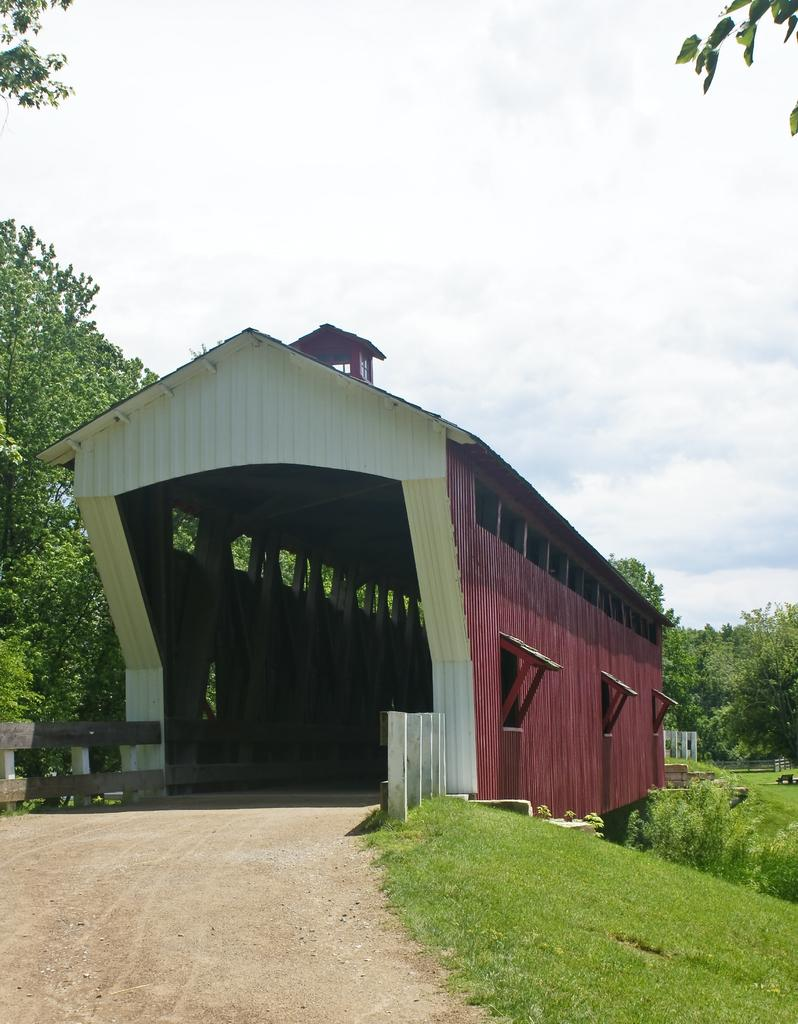What type of structure is visible in the image? There is a shed in the image. What can be seen in the background of the image? There are many trees, plants, and grass in the background of the image. What type of fencing is present on the left side of the image? There is wooden fencing on the left side of the image. What is visible at the top of the image? The sky is visible at the top of the image, and clouds are present in the sky. What type of milk is being produced by the corn in the image? There is no corn or milk present in the image; it features a shed, trees, plants, grass, wooden fencing, and a sky with clouds. 